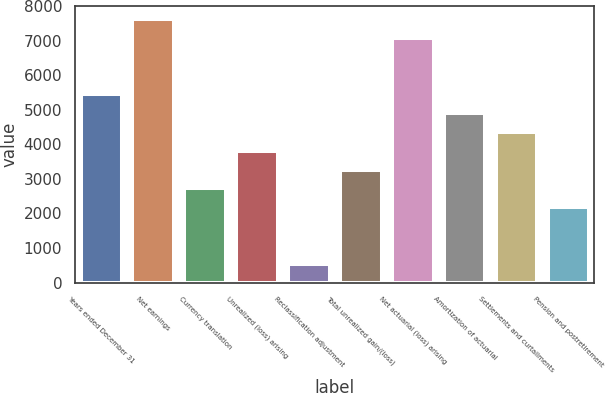Convert chart. <chart><loc_0><loc_0><loc_500><loc_500><bar_chart><fcel>Years ended December 31<fcel>Net earnings<fcel>Currency translation<fcel>Unrealized (loss) arising<fcel>Reclassification adjustment<fcel>Total unrealized gain/(loss)<fcel>Net actuarial (loss) arising<fcel>Amortization of actuarial<fcel>Settlements and curtailments<fcel>Pension and postretirement<nl><fcel>5446<fcel>7622.4<fcel>2725.5<fcel>3813.7<fcel>549.1<fcel>3269.6<fcel>7078.3<fcel>4901.9<fcel>4357.8<fcel>2181.4<nl></chart> 